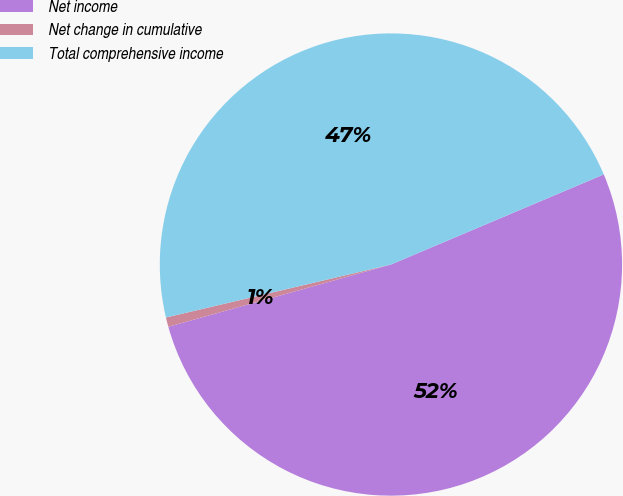Convert chart. <chart><loc_0><loc_0><loc_500><loc_500><pie_chart><fcel>Net income<fcel>Net change in cumulative<fcel>Total comprehensive income<nl><fcel>52.03%<fcel>0.66%<fcel>47.3%<nl></chart> 